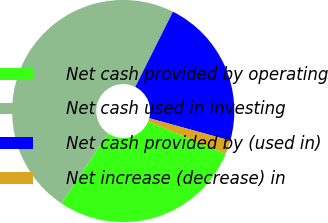<chart> <loc_0><loc_0><loc_500><loc_500><pie_chart><fcel>Net cash provided by operating<fcel>Net cash used in investing<fcel>Net cash provided by (used in)<fcel>Net increase (decrease) in<nl><fcel>28.11%<fcel>47.98%<fcel>21.89%<fcel>2.02%<nl></chart> 